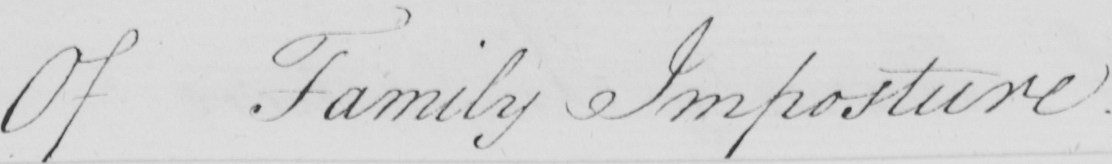Please provide the text content of this handwritten line. Of Family Imposture 